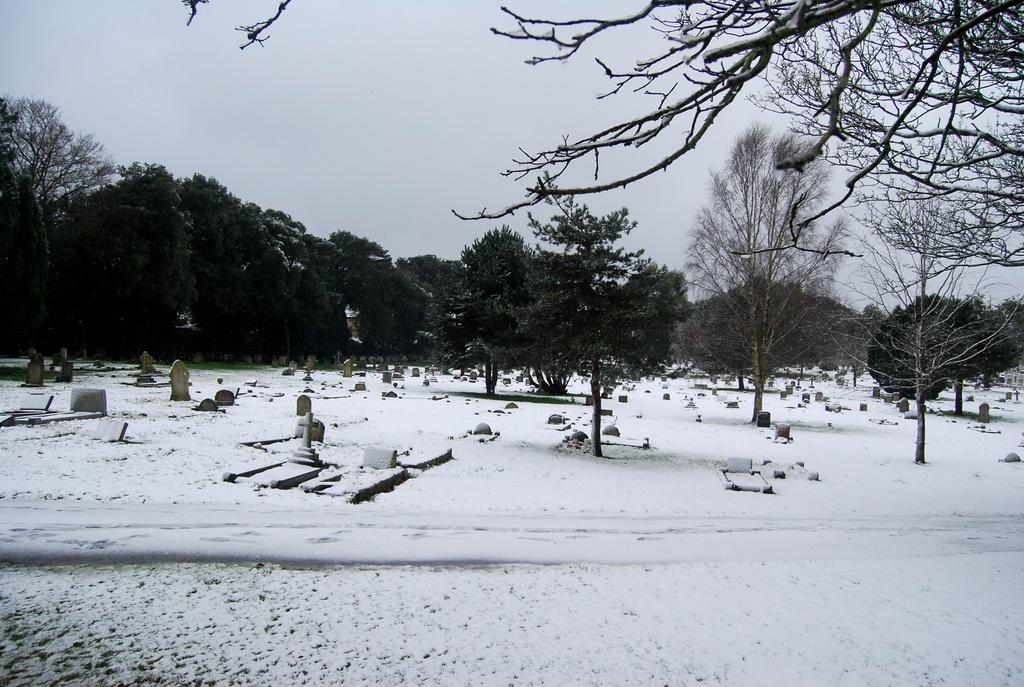What is on the snow in the image? There are objects on the snow in the image. What can be seen in the distance in the image? There are trees in the background of the image. What else is visible in the background of the image? The sky is visible in the background of the image. What type of fuel is being used by the letter in the image? There is no letter or fuel present in the image. What liquid can be seen flowing from the trees in the image? There is no liquid flowing from the trees in the image; the trees are stationary. 